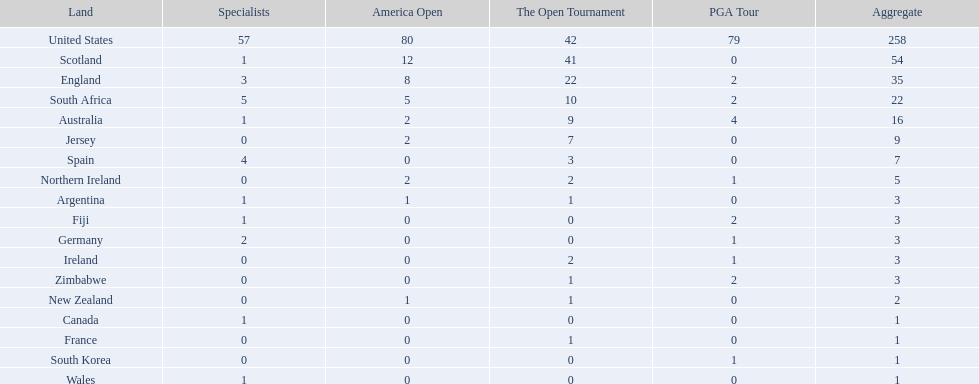What countries in the championship were from africa? South Africa, Zimbabwe. Which of these counteries had the least championship golfers Zimbabwe. 